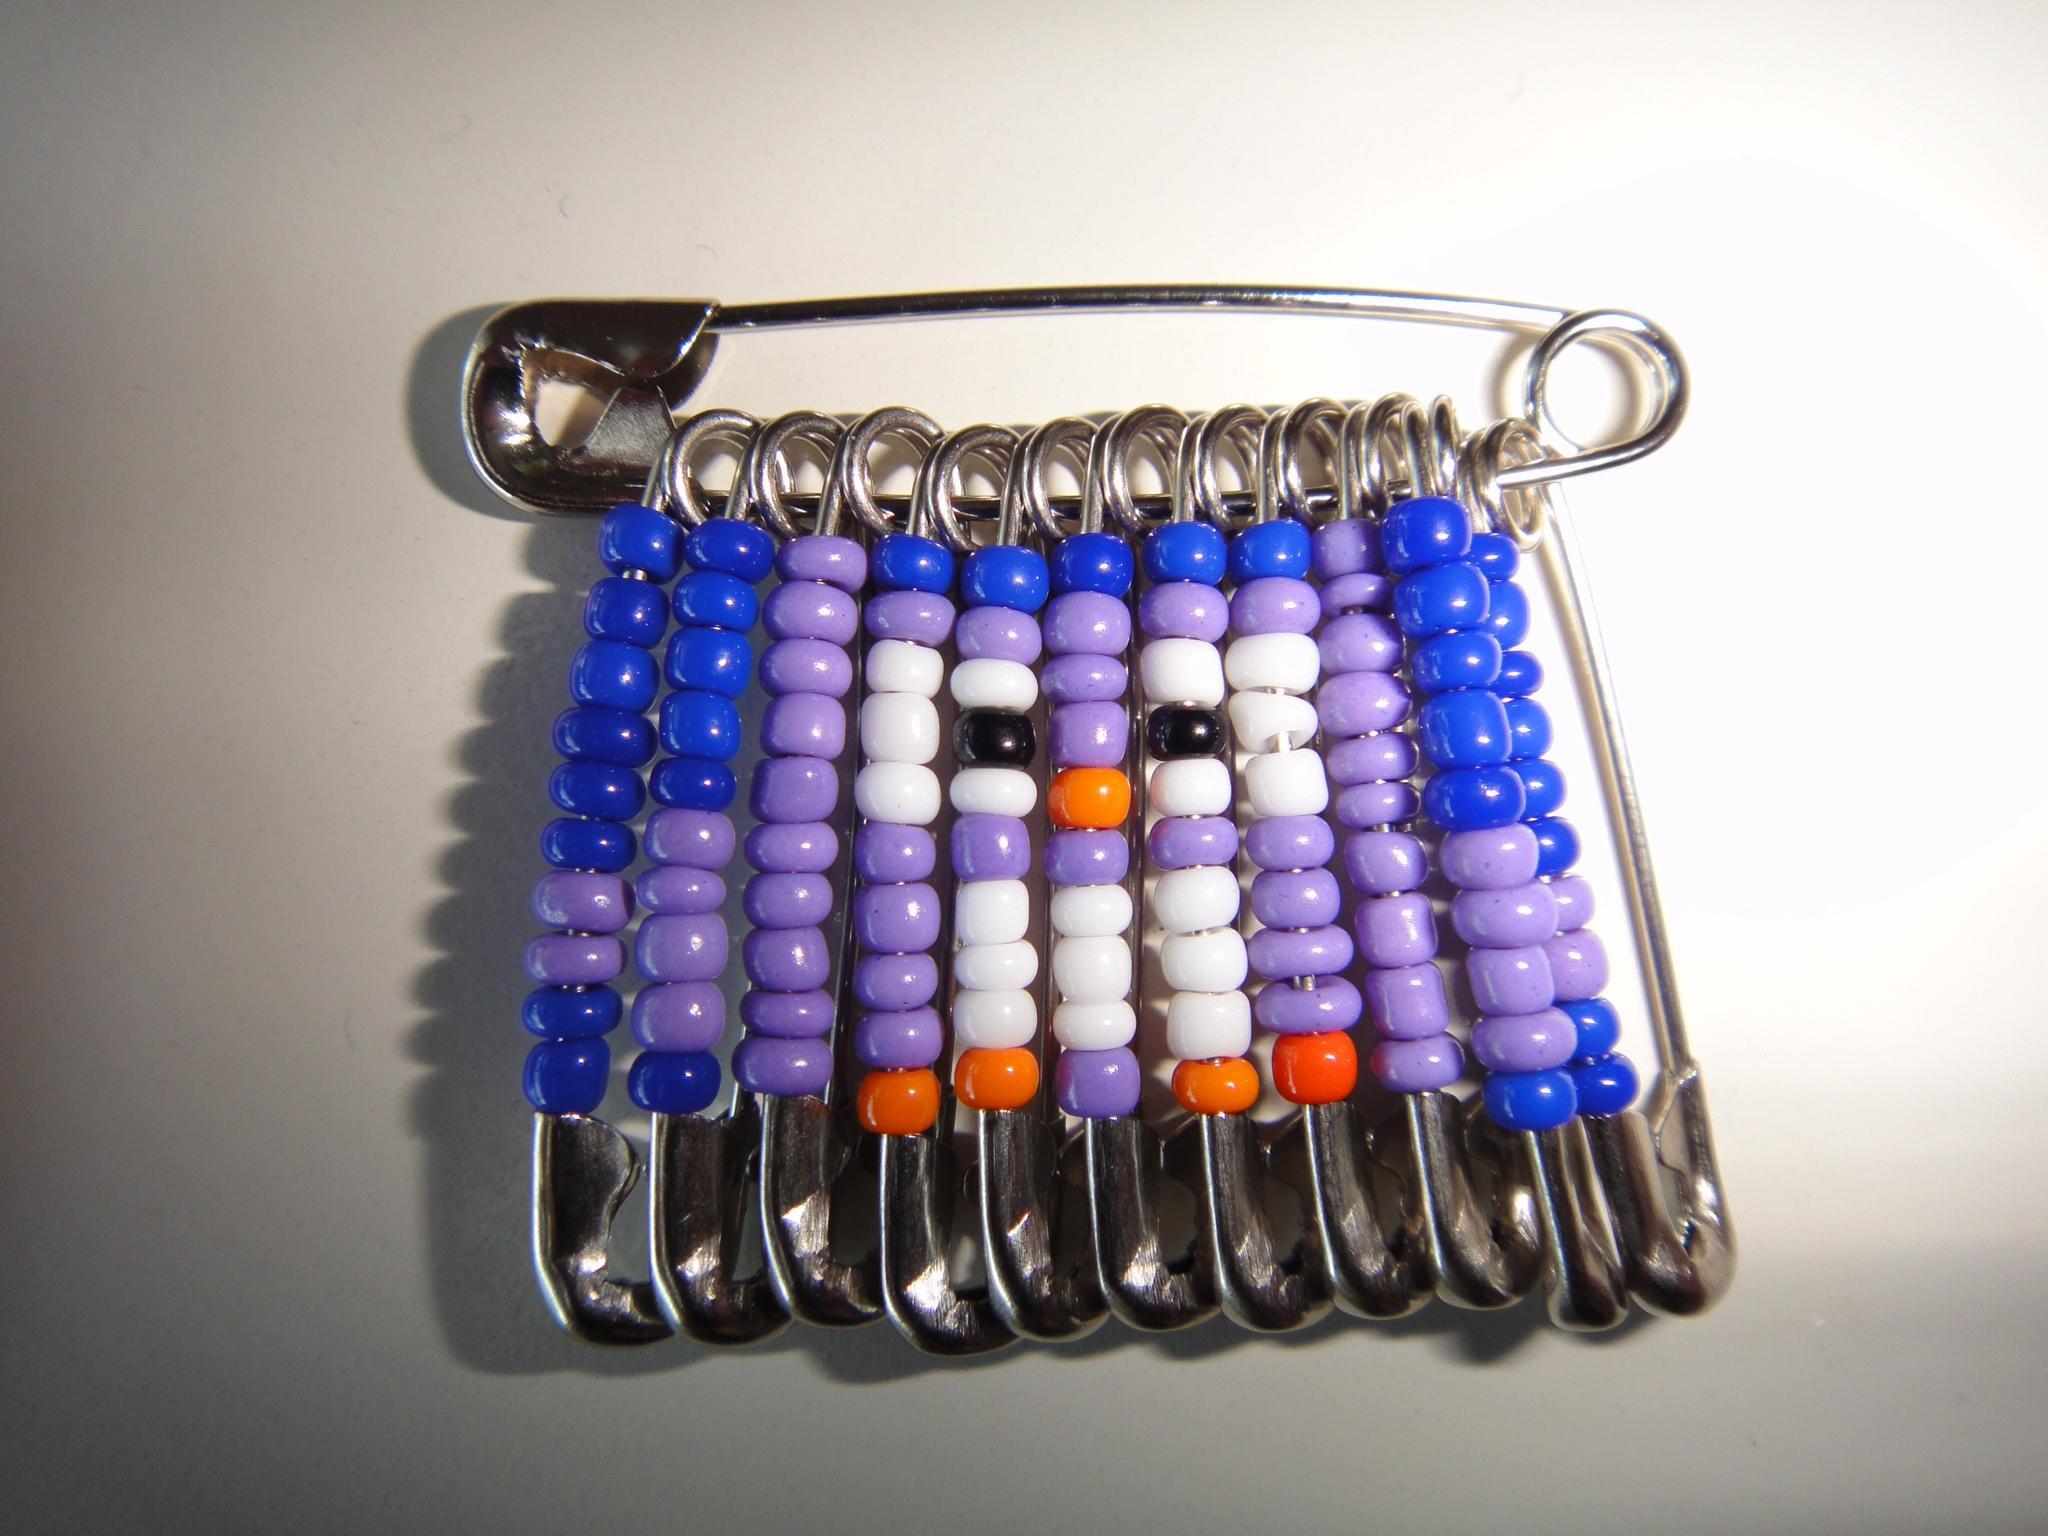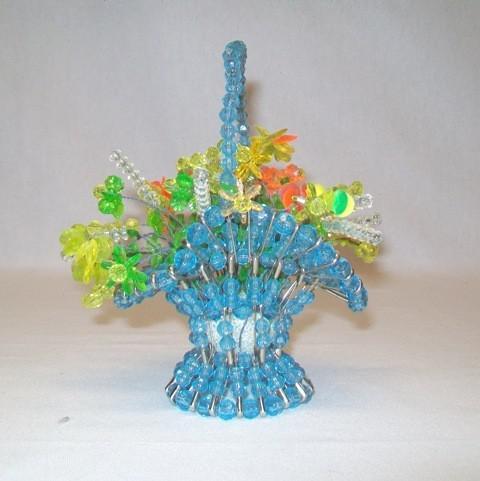The first image is the image on the left, the second image is the image on the right. Assess this claim about the two images: "In one of the pictures, the beads are arranged to resemble an owl.". Correct or not? Answer yes or no. Yes. The first image is the image on the left, the second image is the image on the right. For the images shown, is this caption "An image contains one pin jewelry with colored beads strung on silver safety pins to create a cartoon-like owl image." true? Answer yes or no. Yes. 